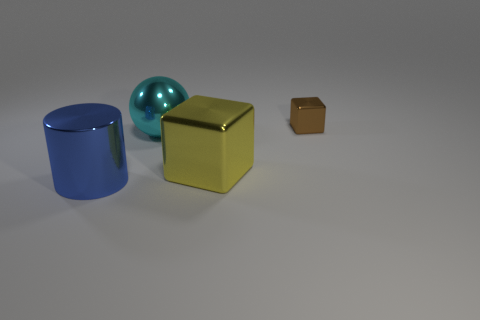Add 2 small brown blocks. How many objects exist? 6 Subtract all spheres. How many objects are left? 3 Add 4 large yellow shiny cubes. How many large yellow shiny cubes are left? 5 Add 2 blue things. How many blue things exist? 3 Subtract 0 gray cylinders. How many objects are left? 4 Subtract all metal cubes. Subtract all big shiny balls. How many objects are left? 1 